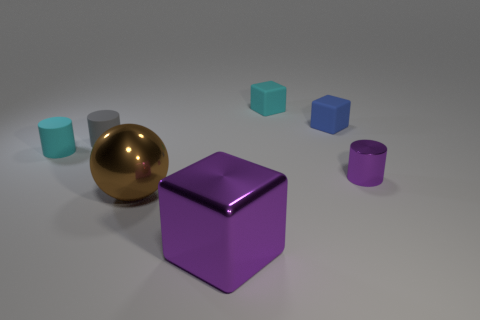What is the arrangement of the objects? The objects are arranged in an asymmetrical composition with a golden sphere, a purple cube at the center, and other cubes of blue and pink hues scattered around the central pieces on a flat surface. 